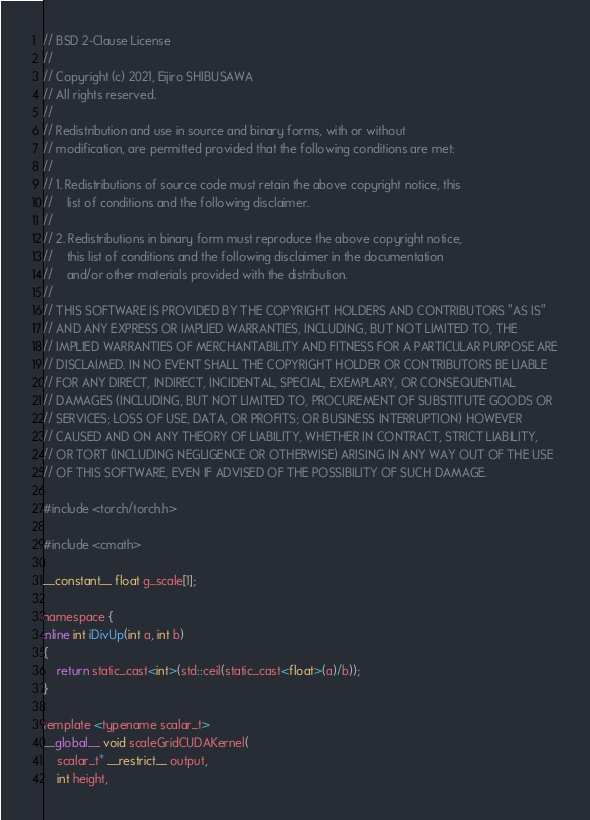<code> <loc_0><loc_0><loc_500><loc_500><_Cuda_>// BSD 2-Clause License
//
// Copyright (c) 2021, Eijiro SHIBUSAWA
// All rights reserved.
//
// Redistribution and use in source and binary forms, with or without
// modification, are permitted provided that the following conditions are met:
//
// 1. Redistributions of source code must retain the above copyright notice, this
//    list of conditions and the following disclaimer.
//
// 2. Redistributions in binary form must reproduce the above copyright notice,
//    this list of conditions and the following disclaimer in the documentation
//    and/or other materials provided with the distribution.
//
// THIS SOFTWARE IS PROVIDED BY THE COPYRIGHT HOLDERS AND CONTRIBUTORS "AS IS"
// AND ANY EXPRESS OR IMPLIED WARRANTIES, INCLUDING, BUT NOT LIMITED TO, THE
// IMPLIED WARRANTIES OF MERCHANTABILITY AND FITNESS FOR A PARTICULAR PURPOSE ARE
// DISCLAIMED. IN NO EVENT SHALL THE COPYRIGHT HOLDER OR CONTRIBUTORS BE LIABLE
// FOR ANY DIRECT, INDIRECT, INCIDENTAL, SPECIAL, EXEMPLARY, OR CONSEQUENTIAL
// DAMAGES (INCLUDING, BUT NOT LIMITED TO, PROCUREMENT OF SUBSTITUTE GOODS OR
// SERVICES; LOSS OF USE, DATA, OR PROFITS; OR BUSINESS INTERRUPTION) HOWEVER
// CAUSED AND ON ANY THEORY OF LIABILITY, WHETHER IN CONTRACT, STRICT LIABILITY,
// OR TORT (INCLUDING NEGLIGENCE OR OTHERWISE) ARISING IN ANY WAY OUT OF THE USE
// OF THIS SOFTWARE, EVEN IF ADVISED OF THE POSSIBILITY OF SUCH DAMAGE.

#include <torch/torch.h>

#include <cmath>

__constant__ float g_scale[1];

namespace {
inline int iDivUp(int a, int b)
{
	return static_cast<int>(std::ceil(static_cast<float>(a)/b));
}

template <typename scalar_t>
__global__ void scaleGridCUDAKernel(
	scalar_t* __restrict__ output,
	int height,</code> 